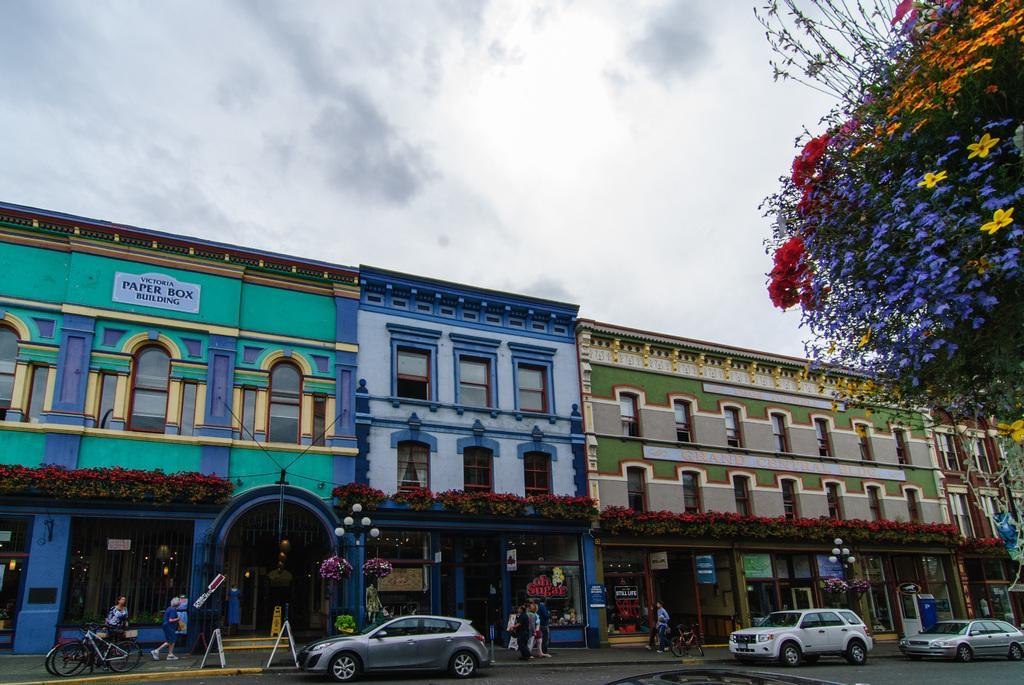Describe this image in one or two sentences. In this image, I can see the buildings with windows, name boards, glass doors and plants with flowers. At the bottom of the image, I can see bicycles, few people standing and cars on the road. On the right side of the image, there is a tree with colorful flowers. In the background, there is the sky. 